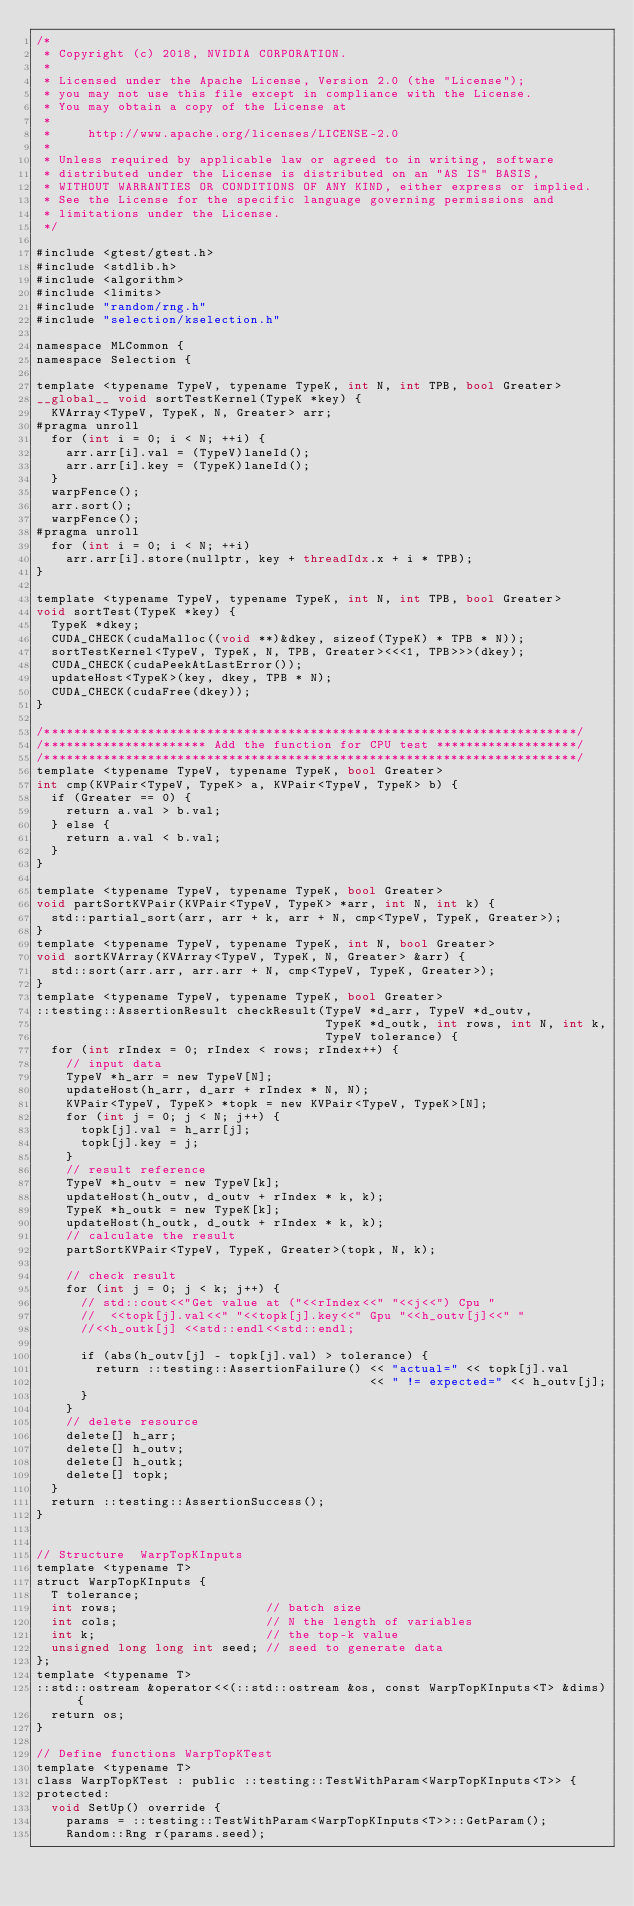<code> <loc_0><loc_0><loc_500><loc_500><_Cuda_>/*
 * Copyright (c) 2018, NVIDIA CORPORATION.
 *
 * Licensed under the Apache License, Version 2.0 (the "License");
 * you may not use this file except in compliance with the License.
 * You may obtain a copy of the License at
 *
 *     http://www.apache.org/licenses/LICENSE-2.0
 *
 * Unless required by applicable law or agreed to in writing, software
 * distributed under the License is distributed on an "AS IS" BASIS,
 * WITHOUT WARRANTIES OR CONDITIONS OF ANY KIND, either express or implied.
 * See the License for the specific language governing permissions and
 * limitations under the License.
 */

#include <gtest/gtest.h>
#include <stdlib.h>
#include <algorithm>
#include <limits>
#include "random/rng.h"
#include "selection/kselection.h"

namespace MLCommon {
namespace Selection {

template <typename TypeV, typename TypeK, int N, int TPB, bool Greater>
__global__ void sortTestKernel(TypeK *key) {
  KVArray<TypeV, TypeK, N, Greater> arr;
#pragma unroll
  for (int i = 0; i < N; ++i) {
    arr.arr[i].val = (TypeV)laneId();
    arr.arr[i].key = (TypeK)laneId();
  }
  warpFence();
  arr.sort();
  warpFence();
#pragma unroll
  for (int i = 0; i < N; ++i)
    arr.arr[i].store(nullptr, key + threadIdx.x + i * TPB);
}

template <typename TypeV, typename TypeK, int N, int TPB, bool Greater>
void sortTest(TypeK *key) {
  TypeK *dkey;
  CUDA_CHECK(cudaMalloc((void **)&dkey, sizeof(TypeK) * TPB * N));
  sortTestKernel<TypeV, TypeK, N, TPB, Greater><<<1, TPB>>>(dkey);
  CUDA_CHECK(cudaPeekAtLastError());
  updateHost<TypeK>(key, dkey, TPB * N);
  CUDA_CHECK(cudaFree(dkey));
}

/************************************************************************/
/********************** Add the function for CPU test *******************/
/************************************************************************/
template <typename TypeV, typename TypeK, bool Greater>
int cmp(KVPair<TypeV, TypeK> a, KVPair<TypeV, TypeK> b) {
  if (Greater == 0) {
    return a.val > b.val;
  } else {
    return a.val < b.val;
  }
}

template <typename TypeV, typename TypeK, bool Greater>
void partSortKVPair(KVPair<TypeV, TypeK> *arr, int N, int k) {
  std::partial_sort(arr, arr + k, arr + N, cmp<TypeV, TypeK, Greater>);
}
template <typename TypeV, typename TypeK, int N, bool Greater>
void sortKVArray(KVArray<TypeV, TypeK, N, Greater> &arr) {
  std::sort(arr.arr, arr.arr + N, cmp<TypeV, TypeK, Greater>);
}
template <typename TypeV, typename TypeK, bool Greater>
::testing::AssertionResult checkResult(TypeV *d_arr, TypeV *d_outv,
                                       TypeK *d_outk, int rows, int N, int k,
                                       TypeV tolerance) {
  for (int rIndex = 0; rIndex < rows; rIndex++) {
    // input data
    TypeV *h_arr = new TypeV[N];
    updateHost(h_arr, d_arr + rIndex * N, N);
    KVPair<TypeV, TypeK> *topk = new KVPair<TypeV, TypeK>[N];
    for (int j = 0; j < N; j++) {
      topk[j].val = h_arr[j];
      topk[j].key = j;
    }
    // result reference
    TypeV *h_outv = new TypeV[k];
    updateHost(h_outv, d_outv + rIndex * k, k);
    TypeK *h_outk = new TypeK[k];
    updateHost(h_outk, d_outk + rIndex * k, k);
    // calculate the result
    partSortKVPair<TypeV, TypeK, Greater>(topk, N, k);

    // check result
    for (int j = 0; j < k; j++) {
      // std::cout<<"Get value at ("<<rIndex<<" "<<j<<") Cpu "
      //  <<topk[j].val<<" "<<topk[j].key<<" Gpu "<<h_outv[j]<<" "
      //<<h_outk[j] <<std::endl<<std::endl;

      if (abs(h_outv[j] - topk[j].val) > tolerance) {
        return ::testing::AssertionFailure() << "actual=" << topk[j].val
                                             << " != expected=" << h_outv[j];
      }
    }
    // delete resource
    delete[] h_arr;
    delete[] h_outv;
    delete[] h_outk;
    delete[] topk;
  }
  return ::testing::AssertionSuccess();
}


// Structure  WarpTopKInputs
template <typename T>
struct WarpTopKInputs {
  T tolerance;
  int rows;                    // batch size
  int cols;                    // N the length of variables
  int k;                       // the top-k value
  unsigned long long int seed; // seed to generate data
};
template <typename T>
::std::ostream &operator<<(::std::ostream &os, const WarpTopKInputs<T> &dims) {
  return os;
}

// Define functions WarpTopKTest
template <typename T>
class WarpTopKTest : public ::testing::TestWithParam<WarpTopKInputs<T>> {
protected:
  void SetUp() override {
    params = ::testing::TestWithParam<WarpTopKInputs<T>>::GetParam();
    Random::Rng r(params.seed);</code> 